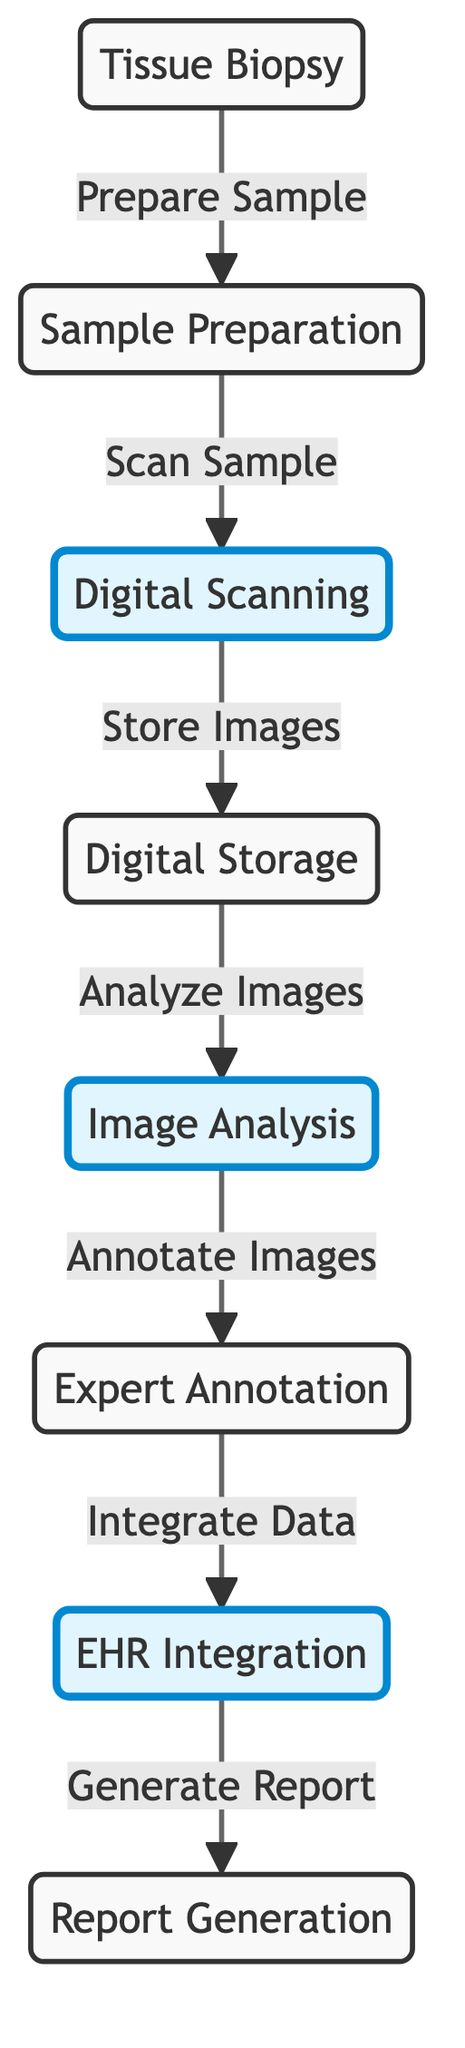What is the first step in the digital pathology workflow? The first node in the diagram is "Tissue Biopsy," indicating that obtaining a tissue biopsy is the starting point of the workflow.
Answer: Tissue Biopsy How many steps are there in the digital pathology workflow? By counting the nodes labeled from "Tissue Biopsy" to "Report Generation," there are a total of 7 steps in the workflow.
Answer: 7 Which step follows the "Digital Scanning"? The diagram shows an arrow leading from "Digital Scanning" to "Digital Storage," meaning that digital storage follows the scanning step in the workflow.
Answer: Digital Storage What action is taken after "Image Analysis"? Following "Image Analysis," the diagram indicates that the next step is called "Expert Annotation," as shown by the arrow connecting these two nodes.
Answer: Expert Annotation Which three steps are highlighted in the diagram? The highlighted steps in the diagram are "Digital Scanning," "Image Analysis," and "EHR Integration," which are visually distinguished from the other steps due to the applied styling.
Answer: Digital Scanning, Image Analysis, EHR Integration What happens during the "EHR Integration"? According to the diagram, during "EHR Integration," the data from previous steps is integrated into the electronic health record system, as per the implied workflow connection.
Answer: Integrate Data Describe the flow from "Sample Preparation" to "Report Generation." The flow starts with "Sample Preparation," leading to "Digital Scanning," then "Digital Storage," followed by "Image Analysis," "Expert Annotation," and finally concludes at "Report Generation," depicting a linear progression through these stages.
Answer: Linear progression through all stated steps How does the diagram visually represent the relationship between each step? The diagram uses arrows to clearly indicate the sequential relationship between each step, showing how one step leads to the next in the digital pathology workflow.
Answer: Arrows indicate sequential relationship 